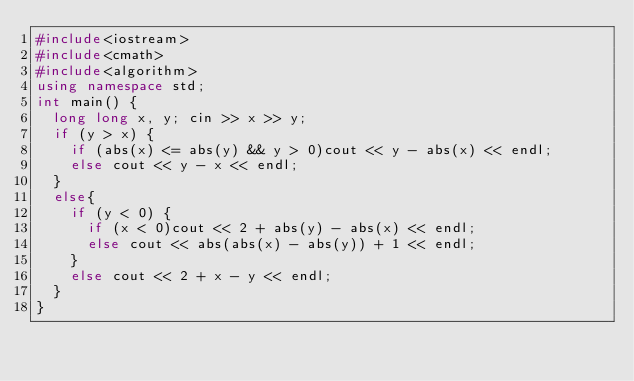<code> <loc_0><loc_0><loc_500><loc_500><_C++_>#include<iostream>
#include<cmath>
#include<algorithm>
using namespace std;
int main() {
	long long x, y; cin >> x >> y;
	if (y > x) {
		if (abs(x) <= abs(y) && y > 0)cout << y - abs(x) << endl;
		else cout << y - x << endl;
	}
	else{
		if (y < 0) {
			if (x < 0)cout << 2 + abs(y) - abs(x) << endl;
			else cout << abs(abs(x) - abs(y)) + 1 << endl;
		}
		else cout << 2 + x - y << endl;
	}
}</code> 